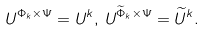<formula> <loc_0><loc_0><loc_500><loc_500>U ^ { \Phi _ { k } \times \Psi } = U ^ { k } , \, U ^ { \widetilde { \Phi } _ { k } \times \Psi } = \widetilde { U } ^ { k } .</formula> 